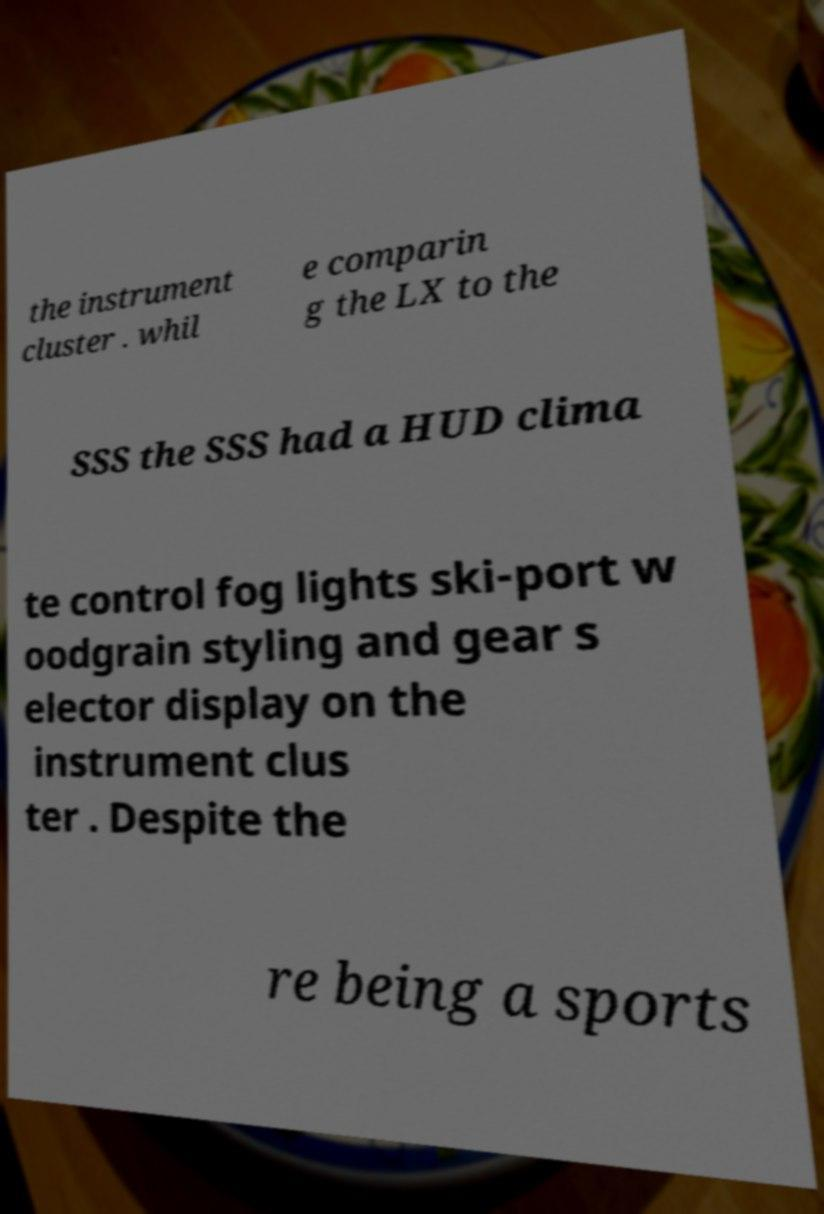What messages or text are displayed in this image? I need them in a readable, typed format. the instrument cluster . whil e comparin g the LX to the SSS the SSS had a HUD clima te control fog lights ski-port w oodgrain styling and gear s elector display on the instrument clus ter . Despite the re being a sports 